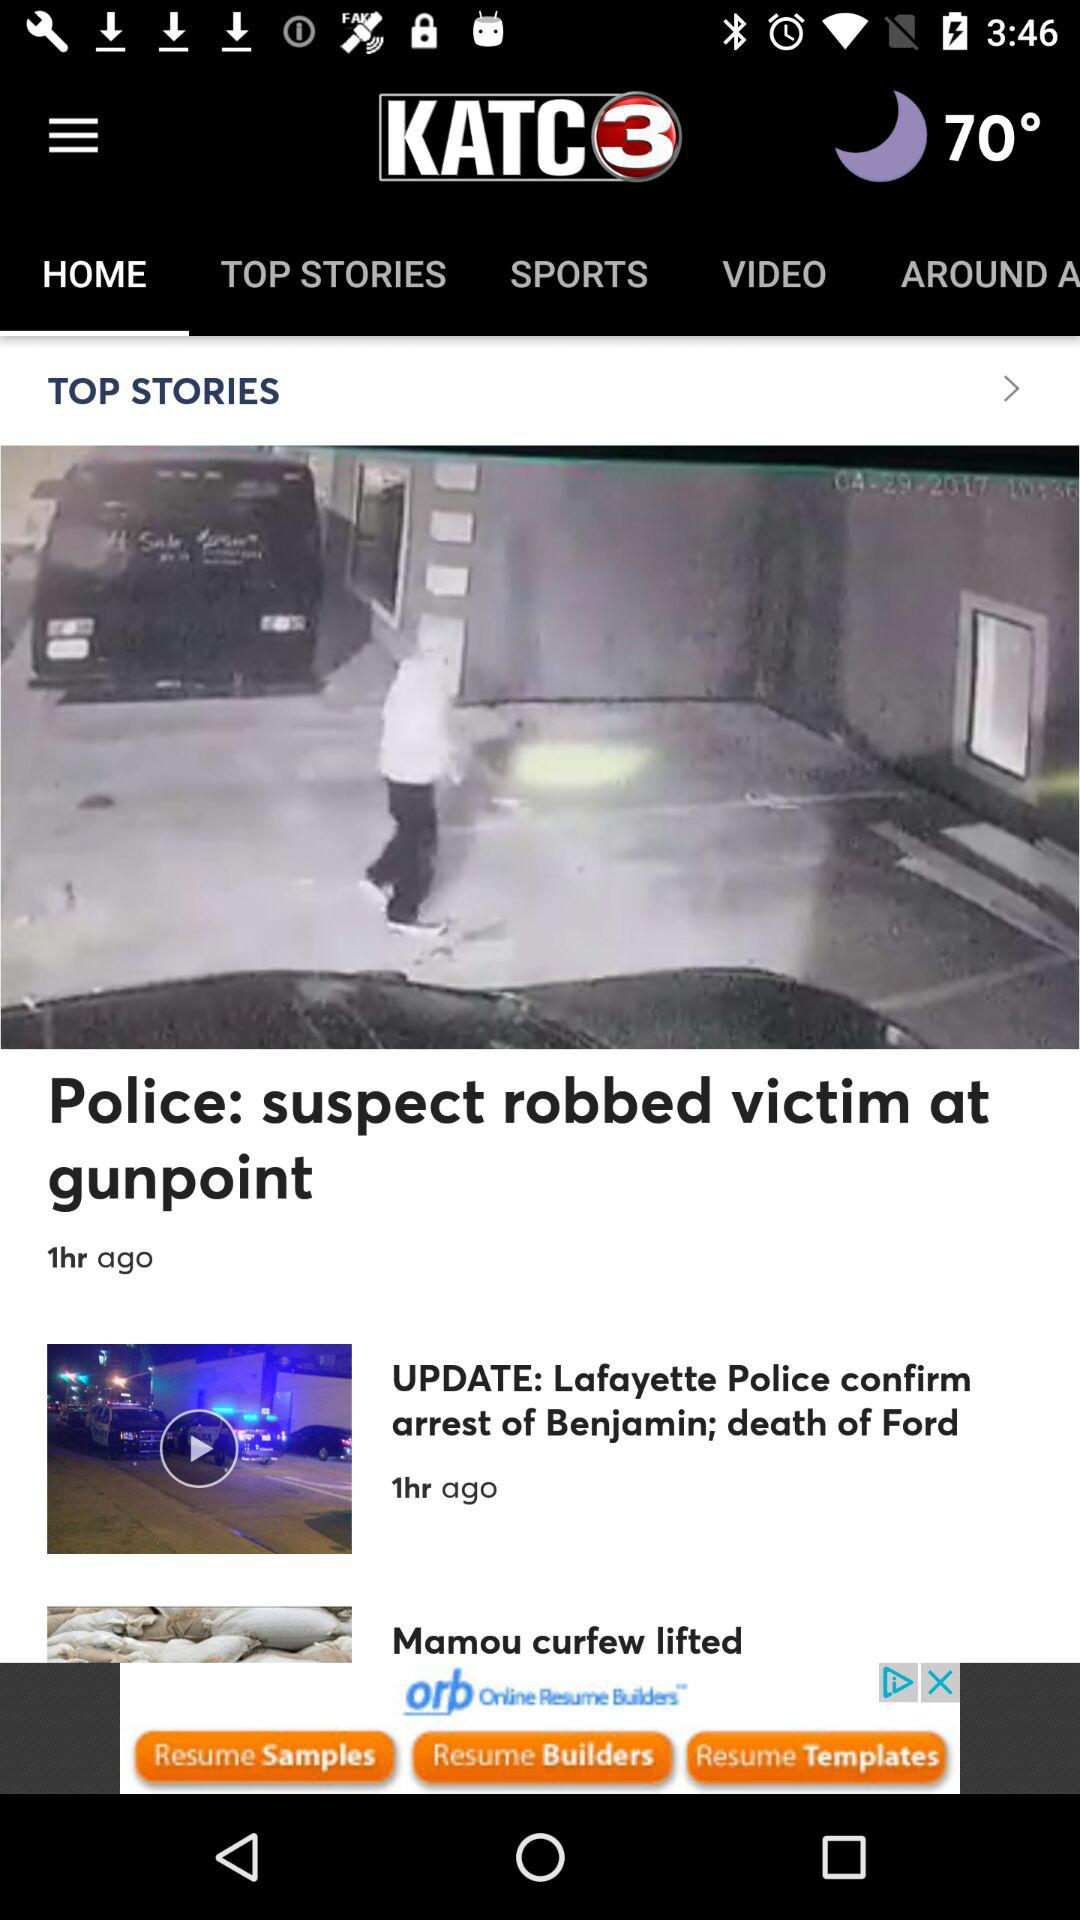When was the news about the arrest of Benjamin and the death of Ford updated? The news about the arrest of Benjamin and the death of Ford was updated 1 hour ago. 